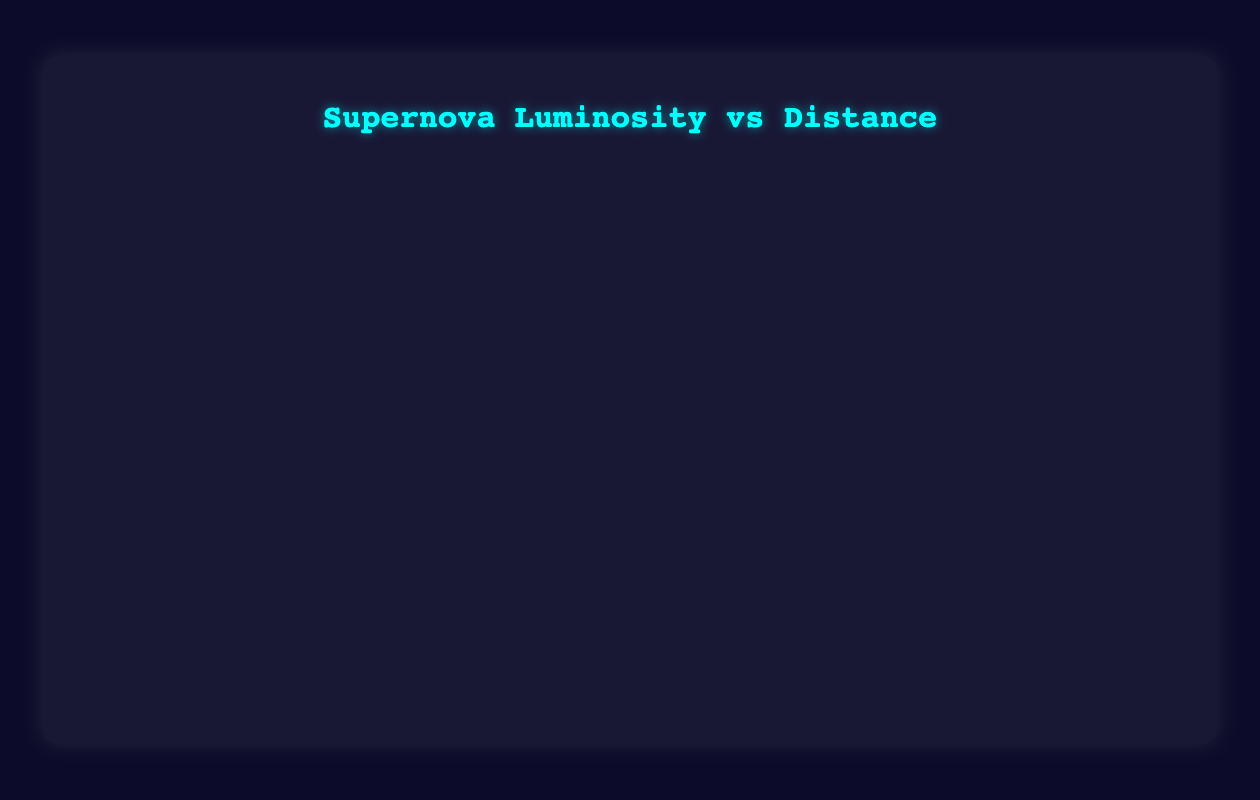What is the title of the bubble chart? The title is displayed at the top of the chart, conveying the primary subject being visualized.
Answer: Supernova Luminosity vs Distance How many supernovae are represented in the bubble chart? By counting the number of distinct bubble entries, each representing a supernova, we discern that there are ten distinct data points.
Answer: 10 What does the y-axis represent and what is its unit? The y-axis title is typically displayed next to the axis. It shows "Luminosity" with the unit denoted in terms of the solar luminosity (L☉), indicating the luminosity of each supernova.
Answer: Luminosity (L☉) Which bubble represents the supernova with the highest luminosity, and what is its type? The bubbles' positions along the y-axis represent luminosity values. The bubble highest on the y-axis corresponds to the highest luminosity, which is SN 2005ap, classified as "Type II-L".
Answer: SN 2005ap, Type II-L Which supernova has the smallest distance from Earth and what is its luminosity? The bubble closest to the origin along the x-axis indicates proximity to Earth. SN 1987A, with a distance of 1.68 Mpc, shows the smallest distance.
Answer: SN 1987A, Luminosity: 2.3e10 L☉ How does the distance of Type Ia supernovae compare? By examining the x-axis positions of bubbles annotated as "Type Ia", we note the distances SN 1994D (14.0 Mpc) and SN 2011fe (6.4 Mpc). SN 2011fe is closer to Earth.
Answer: SN 2011fe is closer to Earth than SN 1994D What was the luminosity of SN 2011fe compared to that of SN 1994D? Compare the y-axis values for SN 2011fe and SN 1994D. SN 2011fe has a luminosity of 1.8e10 L☉, which is greater than SN 1994D's 1.4e10 L☉.
Answer: SN 2011fe has higher luminosity than SN 1994D What is the average luminosity of "Type II-P" supernovae in the chart? Calculate the average by summing the luminosities of Type II-P supernovae (SN 2013ej with 0.6e10 L☉ and SN 1999em with 0.75e10 L☉), then divide by the number of such supernovae (2), (0.6e10 + 0.75e10) / 2 = 0.675e10 L☉.
Answer: 0.675e10 L☉ Which supernova has the largest bubble size, and what does this signify? The bubble size indicates another parameter; the largest bubble represents SN 2005ap with a size of 1.2, indicating perhaps the greatest measured effect or significance.
Answer: SN 2005ap, size 1.2 Which types of supernovae are represented more than once in the chart? Identifying the types repeated among the supernovae listed, Type Ia and Type II-P appear more than once (Type Ia: SN 1994D, SN 2011fe; Type II-P: SN 2013ej, SN 1999em).
Answer: Type Ia and Type II-P 